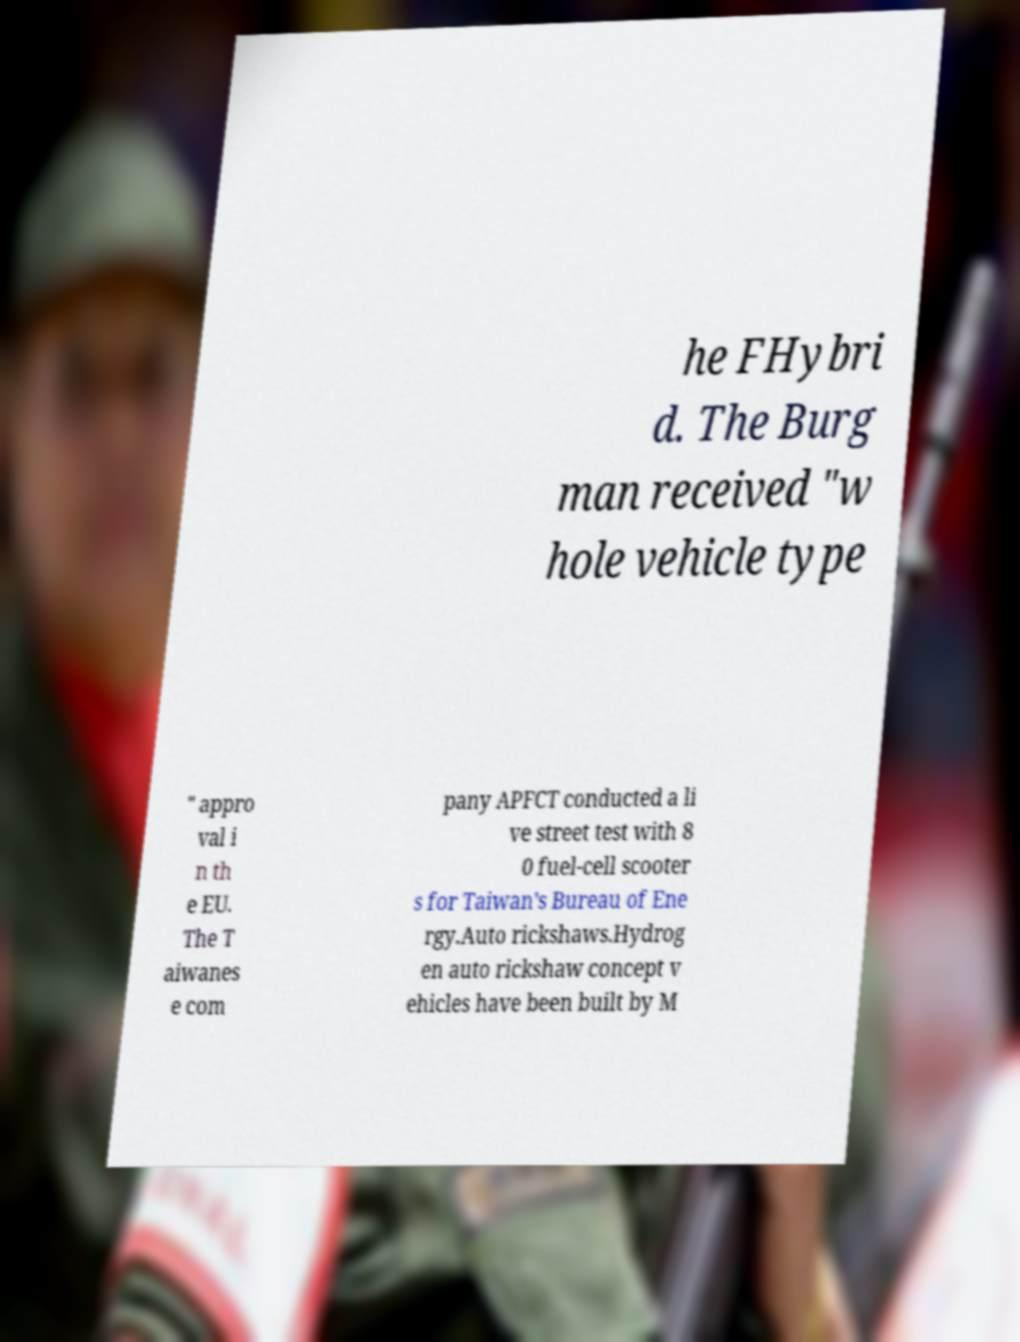Can you read and provide the text displayed in the image?This photo seems to have some interesting text. Can you extract and type it out for me? he FHybri d. The Burg man received "w hole vehicle type " appro val i n th e EU. The T aiwanes e com pany APFCT conducted a li ve street test with 8 0 fuel-cell scooter s for Taiwan's Bureau of Ene rgy.Auto rickshaws.Hydrog en auto rickshaw concept v ehicles have been built by M 